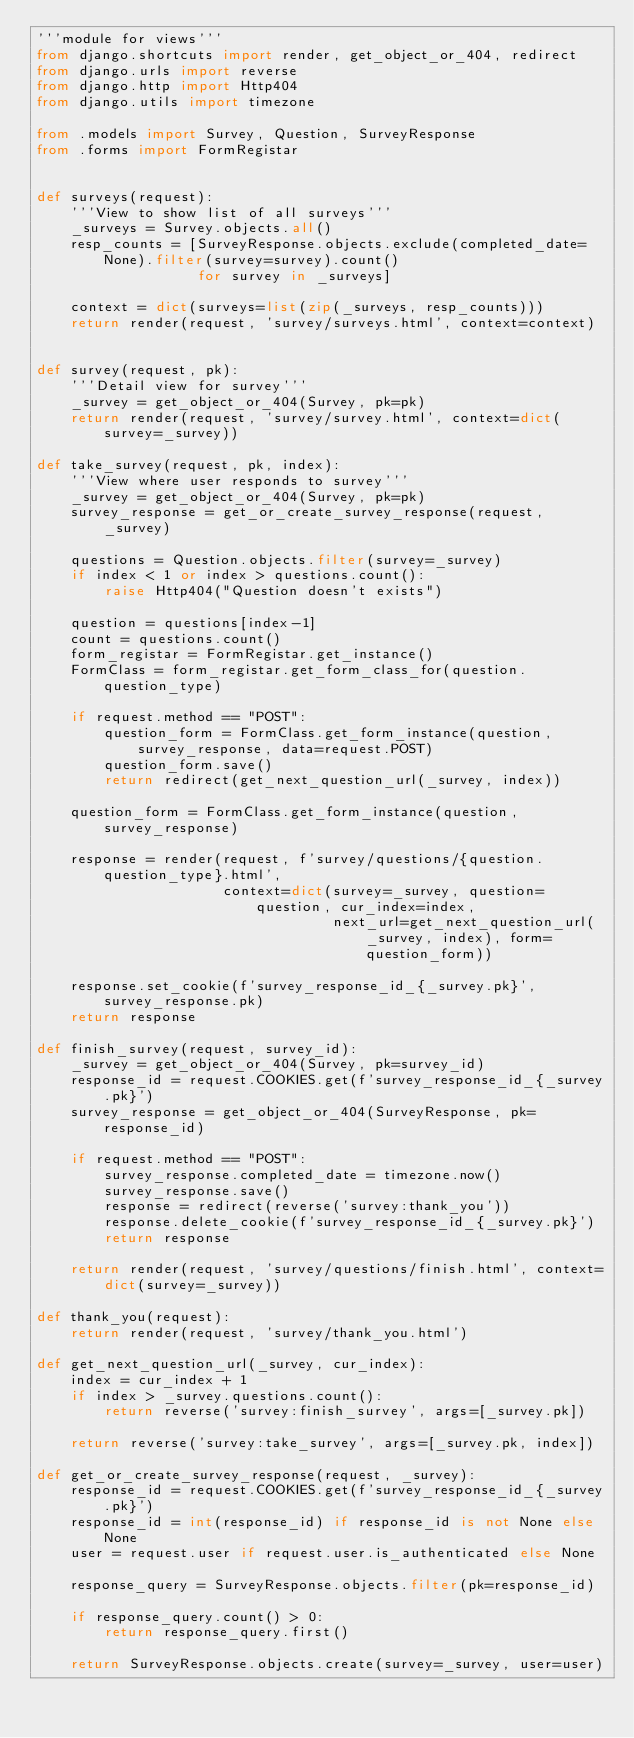Convert code to text. <code><loc_0><loc_0><loc_500><loc_500><_Python_>'''module for views'''
from django.shortcuts import render, get_object_or_404, redirect
from django.urls import reverse
from django.http import Http404
from django.utils import timezone

from .models import Survey, Question, SurveyResponse
from .forms import FormRegistar


def surveys(request):
    '''View to show list of all surveys'''
    _surveys = Survey.objects.all()
    resp_counts = [SurveyResponse.objects.exclude(completed_date=None).filter(survey=survey).count()
                   for survey in _surveys]

    context = dict(surveys=list(zip(_surveys, resp_counts)))
    return render(request, 'survey/surveys.html', context=context)


def survey(request, pk):
    '''Detail view for survey'''
    _survey = get_object_or_404(Survey, pk=pk)
    return render(request, 'survey/survey.html', context=dict(survey=_survey))

def take_survey(request, pk, index):
    '''View where user responds to survey'''
    _survey = get_object_or_404(Survey, pk=pk)
    survey_response = get_or_create_survey_response(request, _survey)

    questions = Question.objects.filter(survey=_survey)
    if index < 1 or index > questions.count():
        raise Http404("Question doesn't exists")

    question = questions[index-1]
    count = questions.count()
    form_registar = FormRegistar.get_instance()
    FormClass = form_registar.get_form_class_for(question.question_type)

    if request.method == "POST":
        question_form = FormClass.get_form_instance(question, survey_response, data=request.POST)
        question_form.save()
        return redirect(get_next_question_url(_survey, index))

    question_form = FormClass.get_form_instance(question, survey_response)

    response = render(request, f'survey/questions/{question.question_type}.html',
                      context=dict(survey=_survey, question=question, cur_index=index,
                                   next_url=get_next_question_url(_survey, index), form=question_form))

    response.set_cookie(f'survey_response_id_{_survey.pk}', survey_response.pk)
    return response

def finish_survey(request, survey_id):
    _survey = get_object_or_404(Survey, pk=survey_id)
    response_id = request.COOKIES.get(f'survey_response_id_{_survey.pk}')
    survey_response = get_object_or_404(SurveyResponse, pk=response_id)

    if request.method == "POST":
        survey_response.completed_date = timezone.now()
        survey_response.save()
        response = redirect(reverse('survey:thank_you'))
        response.delete_cookie(f'survey_response_id_{_survey.pk}')
        return response

    return render(request, 'survey/questions/finish.html', context=dict(survey=_survey))

def thank_you(request):
    return render(request, 'survey/thank_you.html')

def get_next_question_url(_survey, cur_index):
    index = cur_index + 1
    if index > _survey.questions.count():
        return reverse('survey:finish_survey', args=[_survey.pk])

    return reverse('survey:take_survey', args=[_survey.pk, index])    

def get_or_create_survey_response(request, _survey):
    response_id = request.COOKIES.get(f'survey_response_id_{_survey.pk}')
    response_id = int(response_id) if response_id is not None else None
    user = request.user if request.user.is_authenticated else None

    response_query = SurveyResponse.objects.filter(pk=response_id)

    if response_query.count() > 0:
        return response_query.first()

    return SurveyResponse.objects.create(survey=_survey, user=user)
</code> 